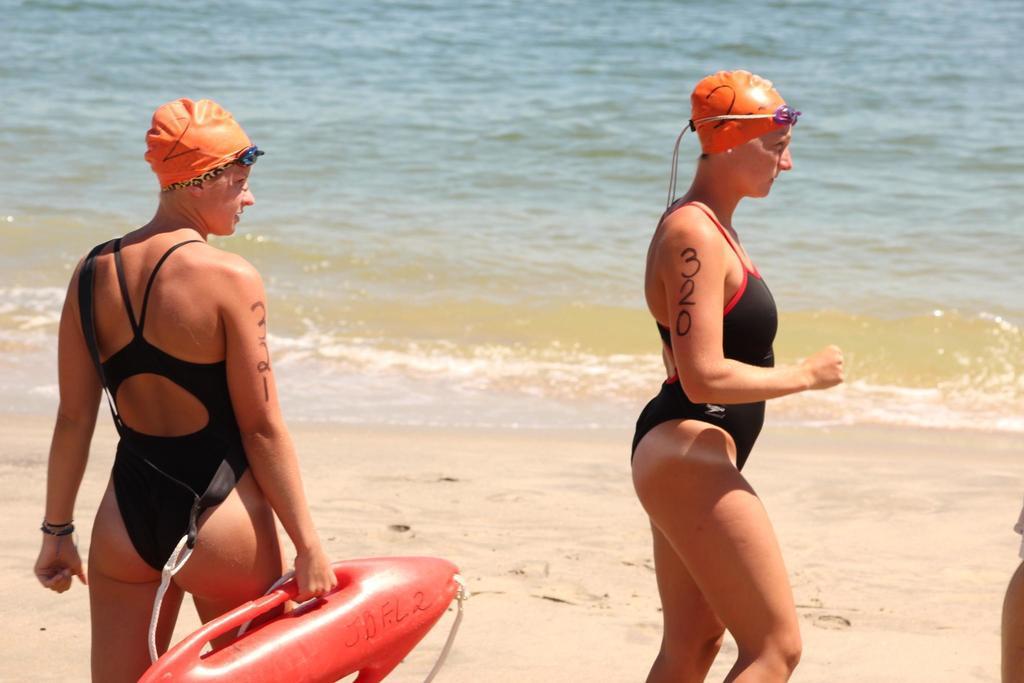In one or two sentences, can you explain what this image depicts? On the left side of the image a lady is standing and wearing hat and holding surfing board. On the right side of the image we can see a lady is walking and wearing hat. In the background of the image we can see water and soil. 